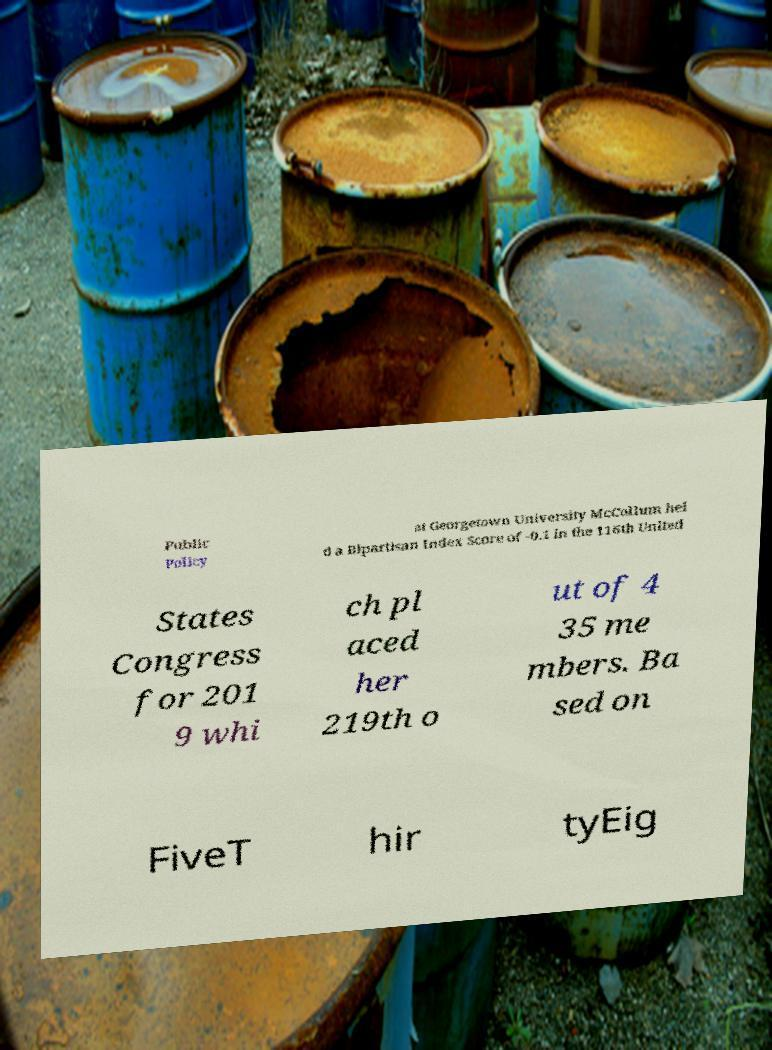Please read and relay the text visible in this image. What does it say? Public Policy at Georgetown University McCollum hel d a Bipartisan Index Score of -0.1 in the 116th United States Congress for 201 9 whi ch pl aced her 219th o ut of 4 35 me mbers. Ba sed on FiveT hir tyEig 